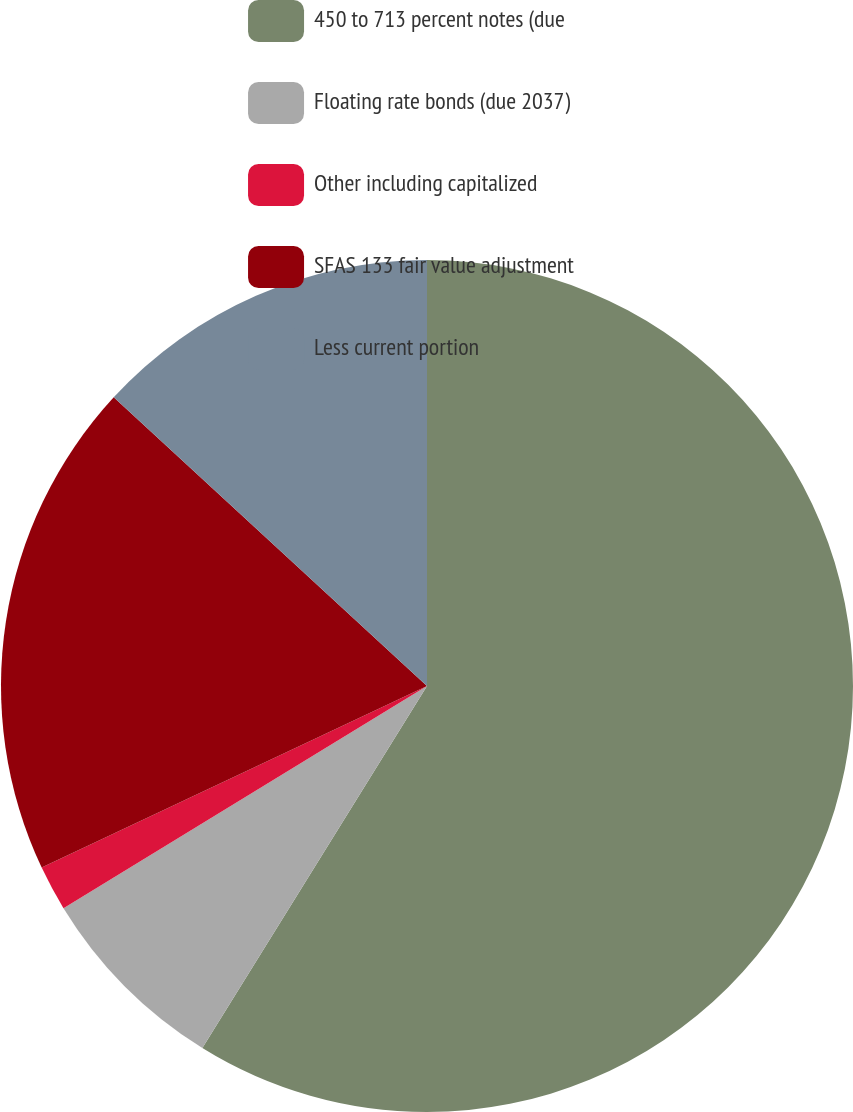Convert chart. <chart><loc_0><loc_0><loc_500><loc_500><pie_chart><fcel>450 to 713 percent notes (due<fcel>Floating rate bonds (due 2037)<fcel>Other including capitalized<fcel>SFAS 133 fair value adjustment<fcel>Less current portion<nl><fcel>58.84%<fcel>7.43%<fcel>1.72%<fcel>18.86%<fcel>13.15%<nl></chart> 